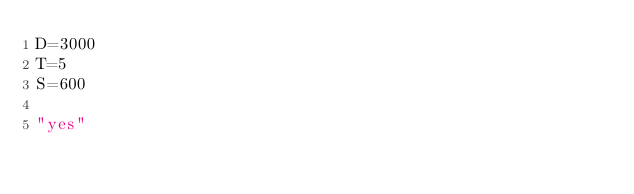Convert code to text. <code><loc_0><loc_0><loc_500><loc_500><_Python_>D=3000
T=5
S=600

"yes"</code> 